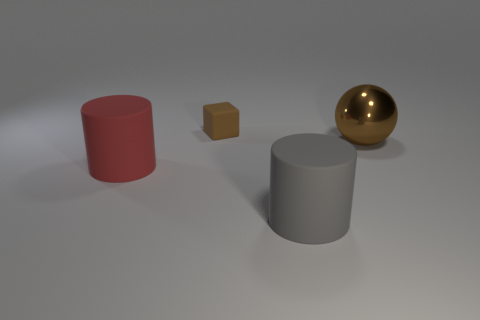Subtract all green balls. Subtract all red cylinders. How many balls are left? 1 Add 1 big red matte cylinders. How many objects exist? 5 Subtract all blocks. How many objects are left? 3 Subtract 1 brown spheres. How many objects are left? 3 Subtract all tiny brown cubes. Subtract all big blue rubber cylinders. How many objects are left? 3 Add 3 small rubber things. How many small rubber things are left? 4 Add 2 small brown things. How many small brown things exist? 3 